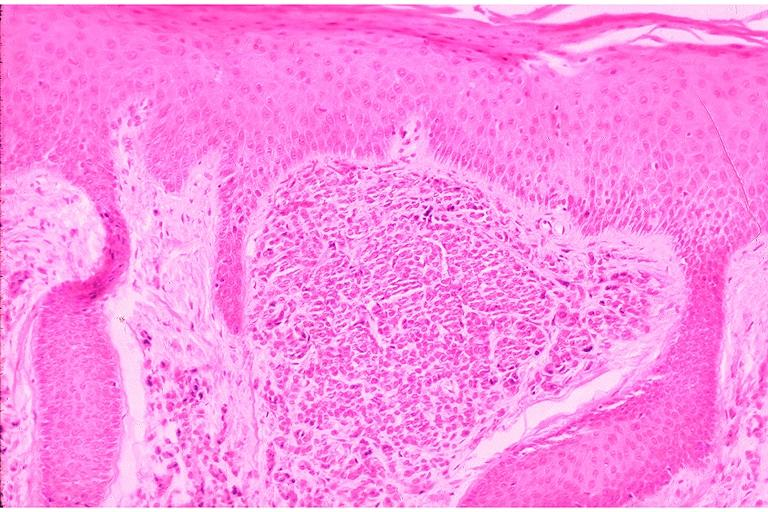where is this?
Answer the question using a single word or phrase. Oral 